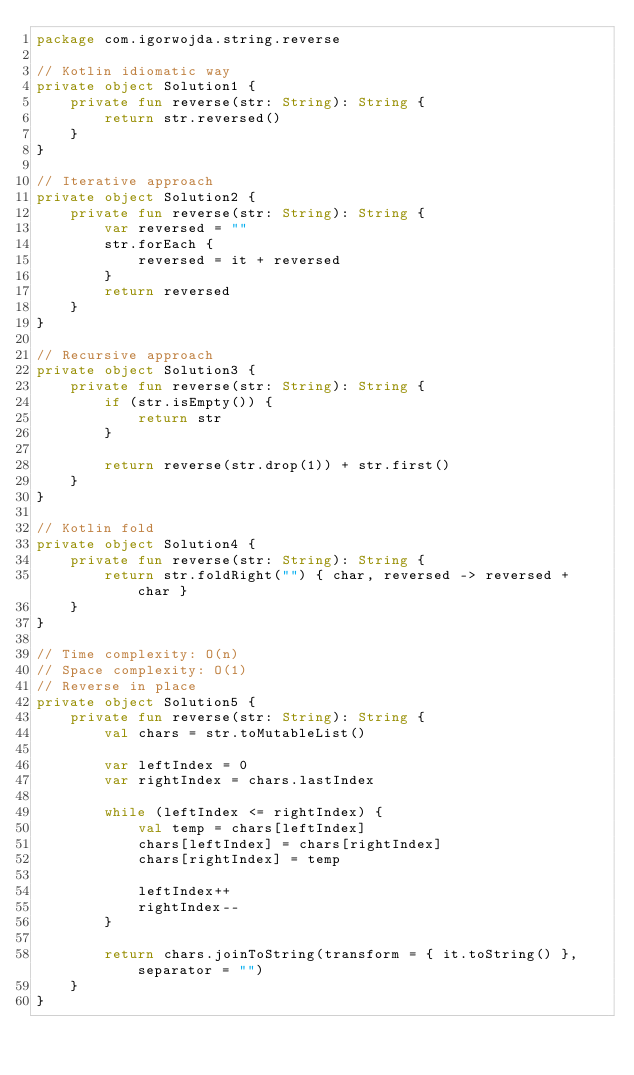Convert code to text. <code><loc_0><loc_0><loc_500><loc_500><_Kotlin_>package com.igorwojda.string.reverse

// Kotlin idiomatic way
private object Solution1 {
    private fun reverse(str: String): String {
        return str.reversed()
    }
}

// Iterative approach
private object Solution2 {
    private fun reverse(str: String): String {
        var reversed = ""
        str.forEach {
            reversed = it + reversed
        }
        return reversed
    }
}

// Recursive approach
private object Solution3 {
    private fun reverse(str: String): String {
        if (str.isEmpty()) {
            return str
        }

        return reverse(str.drop(1)) + str.first()
    }
}

// Kotlin fold
private object Solution4 {
    private fun reverse(str: String): String {
        return str.foldRight("") { char, reversed -> reversed + char }
    }
}

// Time complexity: O(n)
// Space complexity: O(1)
// Reverse in place
private object Solution5 {
    private fun reverse(str: String): String {
        val chars = str.toMutableList()

        var leftIndex = 0
        var rightIndex = chars.lastIndex

        while (leftIndex <= rightIndex) {
            val temp = chars[leftIndex]
            chars[leftIndex] = chars[rightIndex]
            chars[rightIndex] = temp

            leftIndex++
            rightIndex--
        }

        return chars.joinToString(transform = { it.toString() }, separator = "")
    }
}</code> 